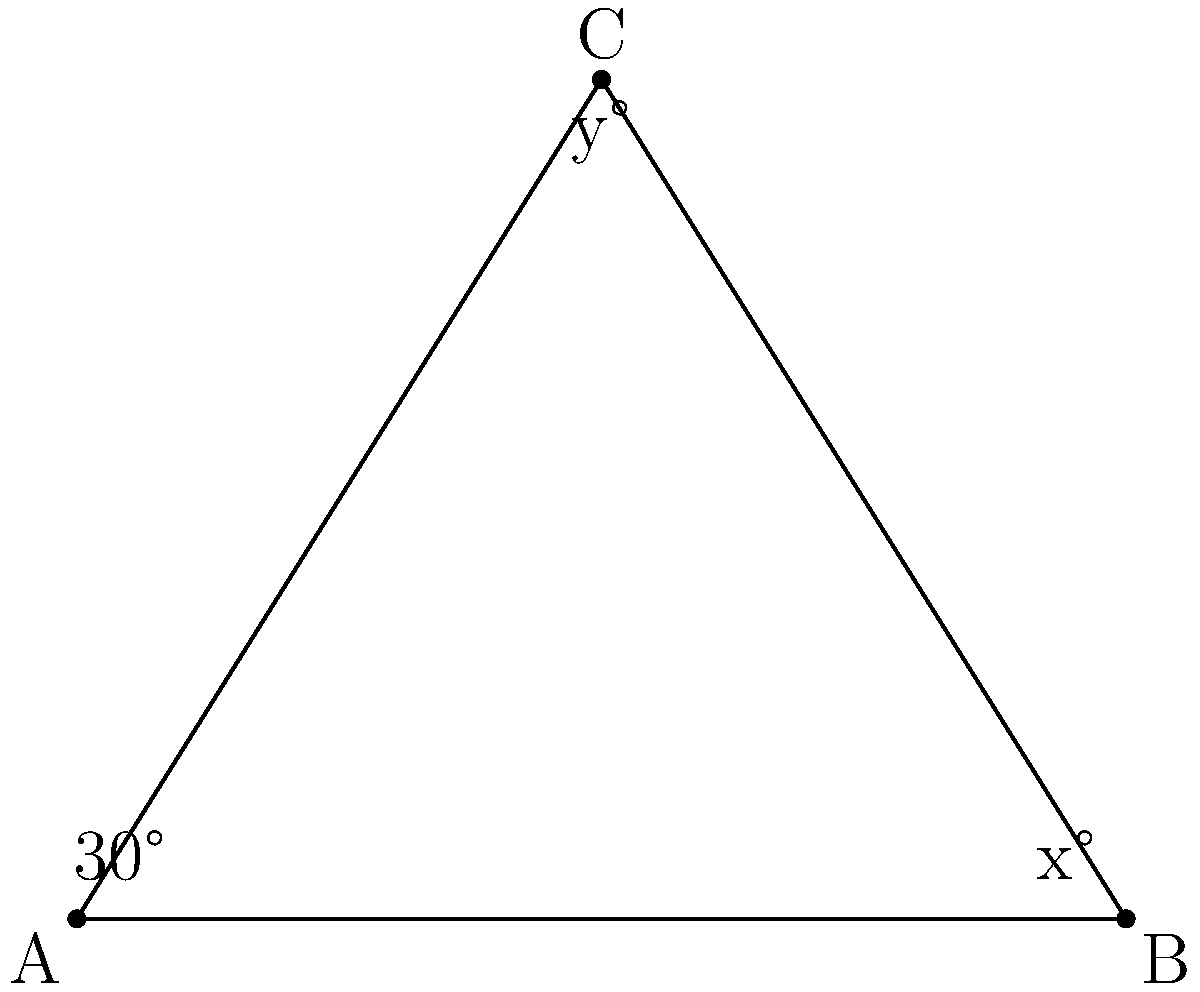During our bus ride to campus, you notice a triangular road sign. The sign forms a right triangle with a 30° angle at the base. If a line is drawn from the top vertex to the midpoint of the base, creating two smaller triangles, what is the measure of angle y in the diagram? Let's approach this step-by-step:

1) In a right triangle, the sum of all angles is 180°. We know one angle is 90° (right angle) and another is 30°.
   
   $90° + 30° + x° = 180°$
   $120° + x° = 180°$
   $x° = 60°$

2) The line drawn from the top vertex to the midpoint of the base creates two smaller right triangles. This line is perpendicular to the base, forming a 90° angle.

3) In the right triangle on the right side:
   - We know the angle at the base is 60° (x)
   - The angle at the vertex where the line meets the base is 90°
   - Therefore, $y° + 60° + 90° = 180°$

4) Solving for y:
   $y° + 150° = 180°$
   $y° = 30°$

Thus, the measure of angle y is 30°.
Answer: 30° 